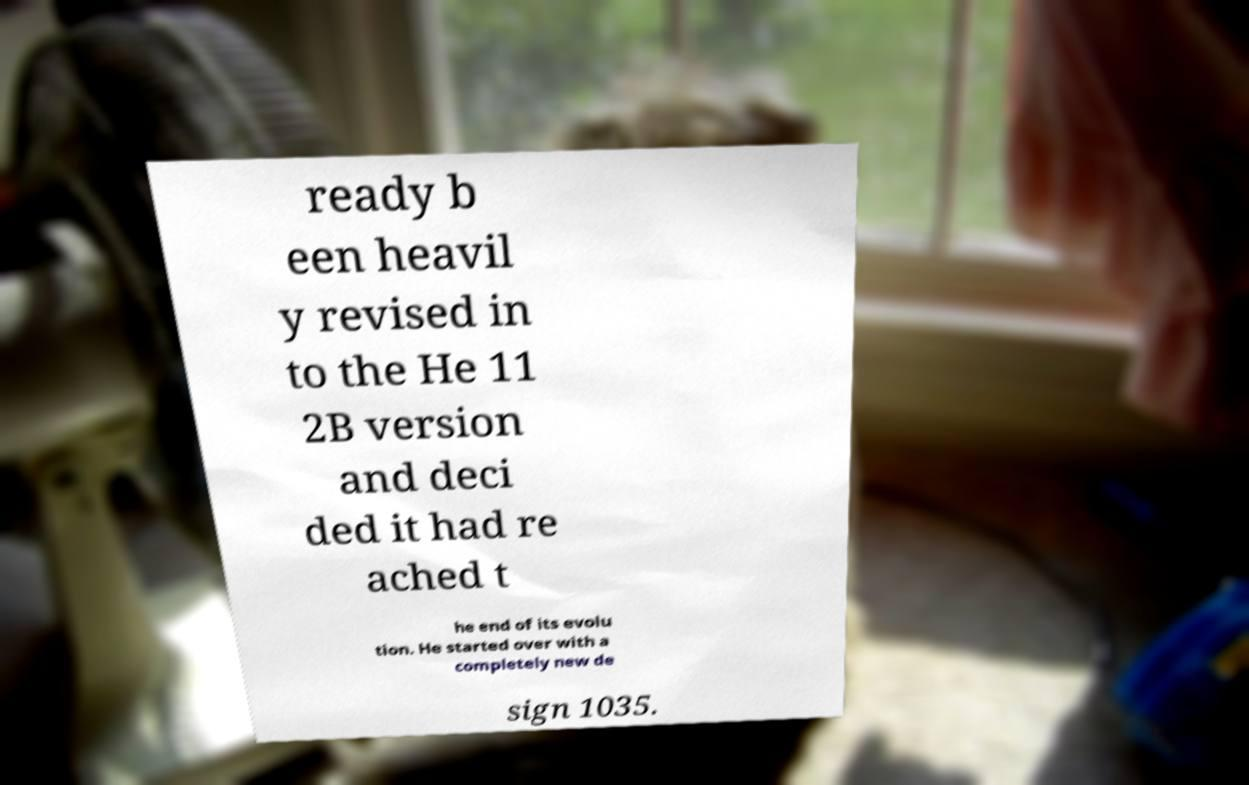Please read and relay the text visible in this image. What does it say? ready b een heavil y revised in to the He 11 2B version and deci ded it had re ached t he end of its evolu tion. He started over with a completely new de sign 1035. 